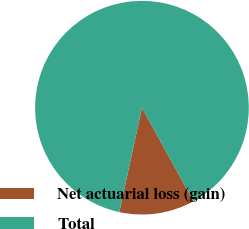Convert chart. <chart><loc_0><loc_0><loc_500><loc_500><pie_chart><fcel>Net actuarial loss (gain)<fcel>Total<nl><fcel>11.43%<fcel>88.57%<nl></chart> 